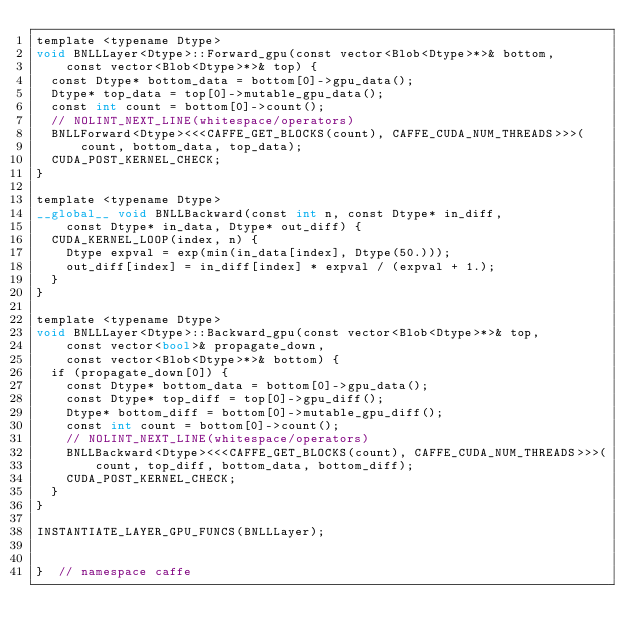Convert code to text. <code><loc_0><loc_0><loc_500><loc_500><_Cuda_>template <typename Dtype>
void BNLLLayer<Dtype>::Forward_gpu(const vector<Blob<Dtype>*>& bottom,
    const vector<Blob<Dtype>*>& top) {
  const Dtype* bottom_data = bottom[0]->gpu_data();
  Dtype* top_data = top[0]->mutable_gpu_data();
  const int count = bottom[0]->count();
  // NOLINT_NEXT_LINE(whitespace/operators)
  BNLLForward<Dtype><<<CAFFE_GET_BLOCKS(count), CAFFE_CUDA_NUM_THREADS>>>(
      count, bottom_data, top_data);
  CUDA_POST_KERNEL_CHECK;
}

template <typename Dtype>
__global__ void BNLLBackward(const int n, const Dtype* in_diff,
    const Dtype* in_data, Dtype* out_diff) {
  CUDA_KERNEL_LOOP(index, n) {
    Dtype expval = exp(min(in_data[index], Dtype(50.)));
    out_diff[index] = in_diff[index] * expval / (expval + 1.);
  }
}

template <typename Dtype>
void BNLLLayer<Dtype>::Backward_gpu(const vector<Blob<Dtype>*>& top,
    const vector<bool>& propagate_down,
    const vector<Blob<Dtype>*>& bottom) {
  if (propagate_down[0]) {
    const Dtype* bottom_data = bottom[0]->gpu_data();
    const Dtype* top_diff = top[0]->gpu_diff();
    Dtype* bottom_diff = bottom[0]->mutable_gpu_diff();
    const int count = bottom[0]->count();
    // NOLINT_NEXT_LINE(whitespace/operators)
    BNLLBackward<Dtype><<<CAFFE_GET_BLOCKS(count), CAFFE_CUDA_NUM_THREADS>>>(
        count, top_diff, bottom_data, bottom_diff);
    CUDA_POST_KERNEL_CHECK;
  }
}

INSTANTIATE_LAYER_GPU_FUNCS(BNLLLayer);


}  // namespace caffe
</code> 